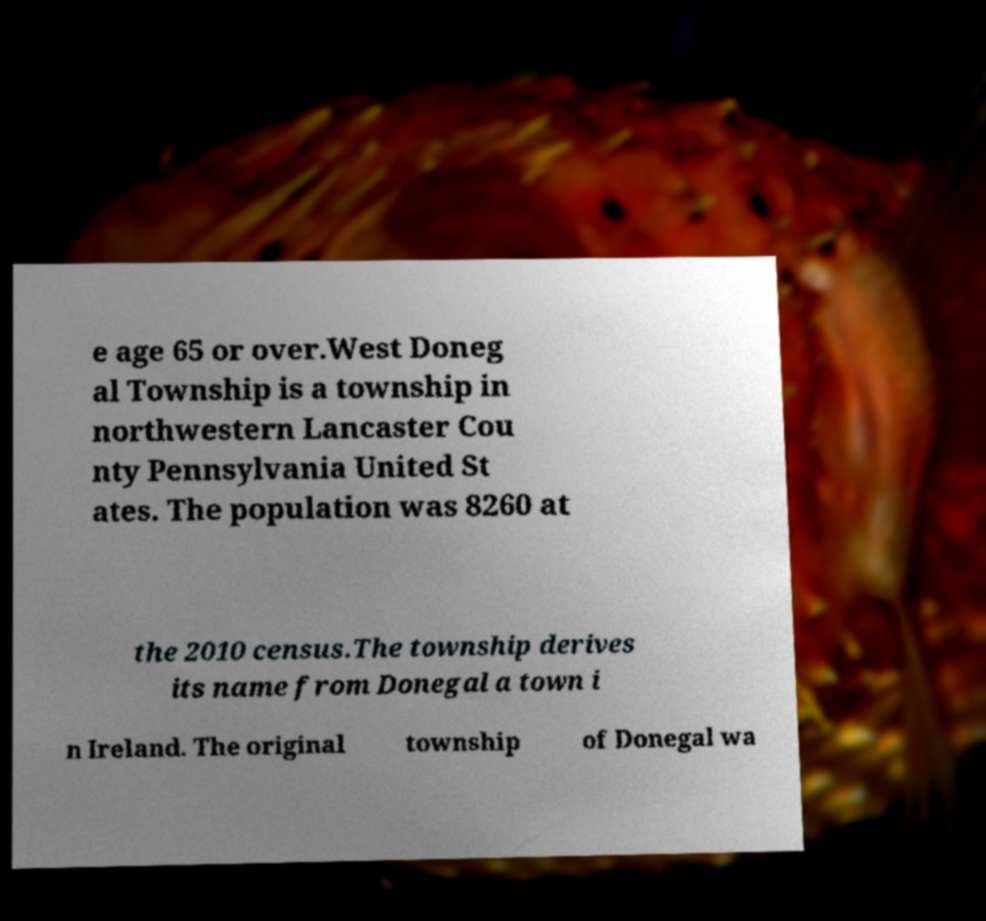Could you assist in decoding the text presented in this image and type it out clearly? e age 65 or over.West Doneg al Township is a township in northwestern Lancaster Cou nty Pennsylvania United St ates. The population was 8260 at the 2010 census.The township derives its name from Donegal a town i n Ireland. The original township of Donegal wa 